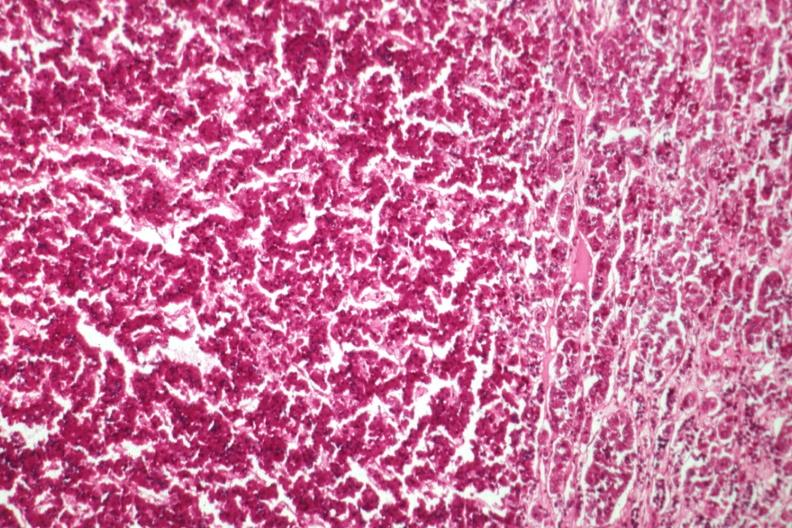s marked present?
Answer the question using a single word or phrase. No 